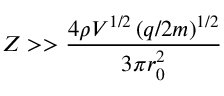<formula> <loc_0><loc_0><loc_500><loc_500>Z > > \frac { 4 \rho V ^ { 1 / 2 } \left ( q / 2 m \right ) ^ { 1 / 2 } } { 3 \pi r _ { 0 } ^ { 2 } }</formula> 